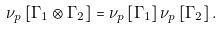<formula> <loc_0><loc_0><loc_500><loc_500>\nu _ { p } \left [ \Gamma _ { 1 } \otimes \Gamma _ { 2 } \right ] = \nu _ { p } \left [ \Gamma _ { 1 } \right ] \nu _ { p } \left [ \Gamma _ { 2 } \right ] .</formula> 